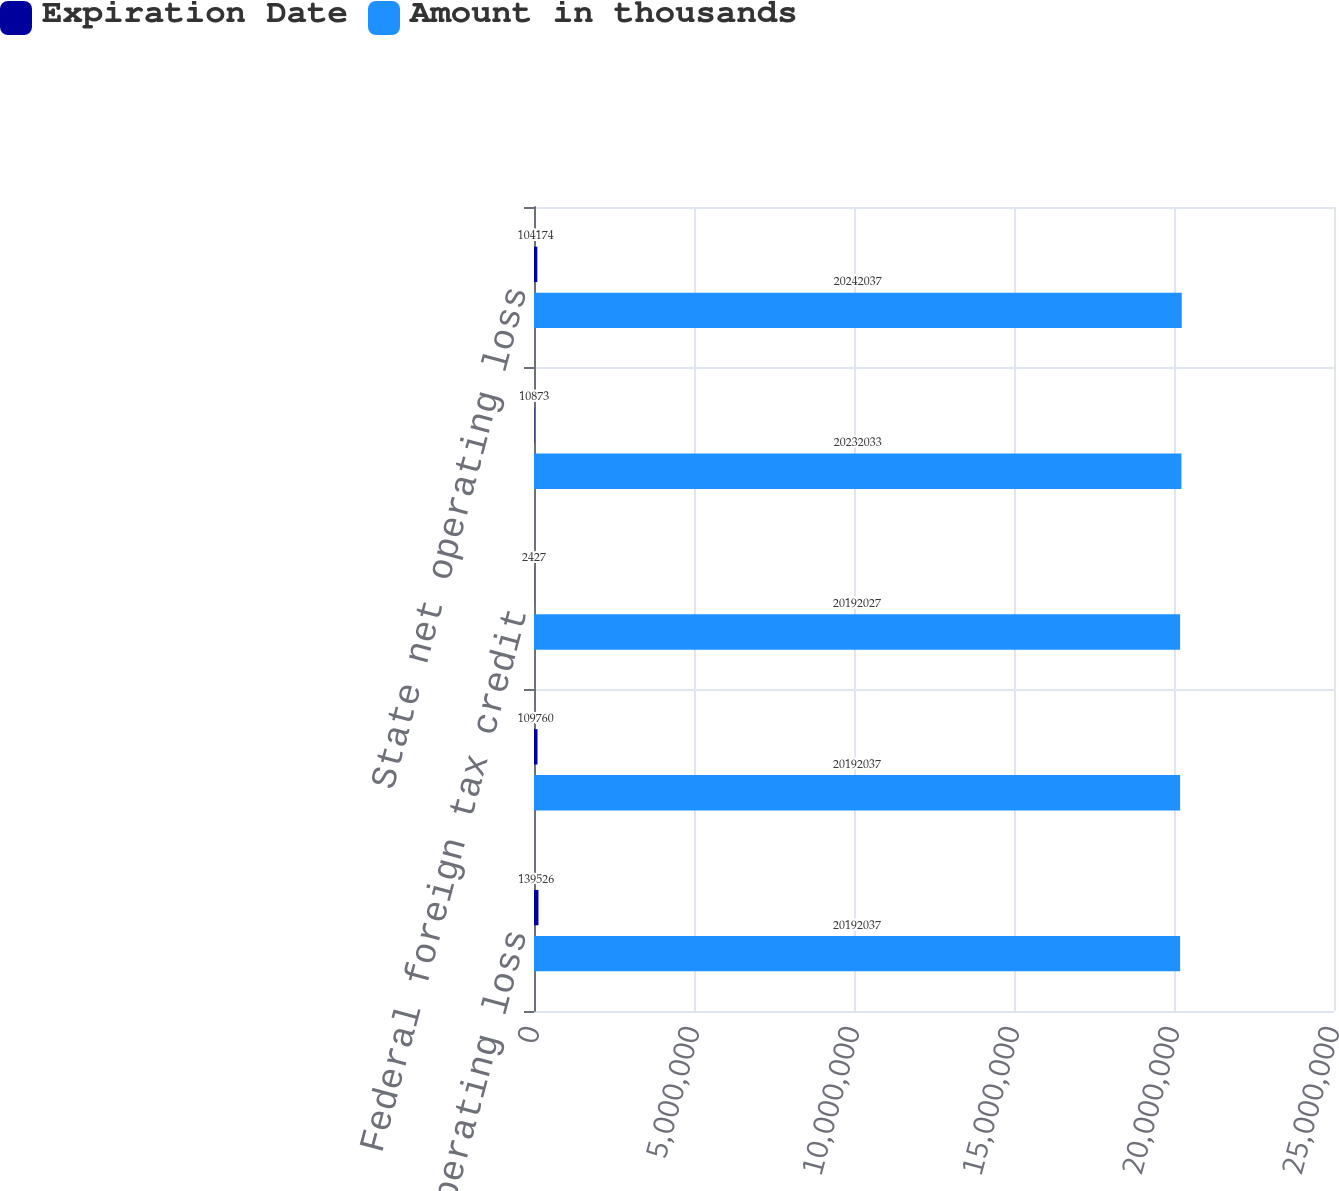<chart> <loc_0><loc_0><loc_500><loc_500><stacked_bar_chart><ecel><fcel>Federal net operating loss<fcel>Federal research credit<fcel>Federal foreign tax credit<fcel>Other state research credit<fcel>State net operating loss<nl><fcel>Expiration Date<fcel>139526<fcel>109760<fcel>2427<fcel>10873<fcel>104174<nl><fcel>Amount in thousands<fcel>2.0192e+07<fcel>2.0192e+07<fcel>2.0192e+07<fcel>2.0232e+07<fcel>2.0242e+07<nl></chart> 